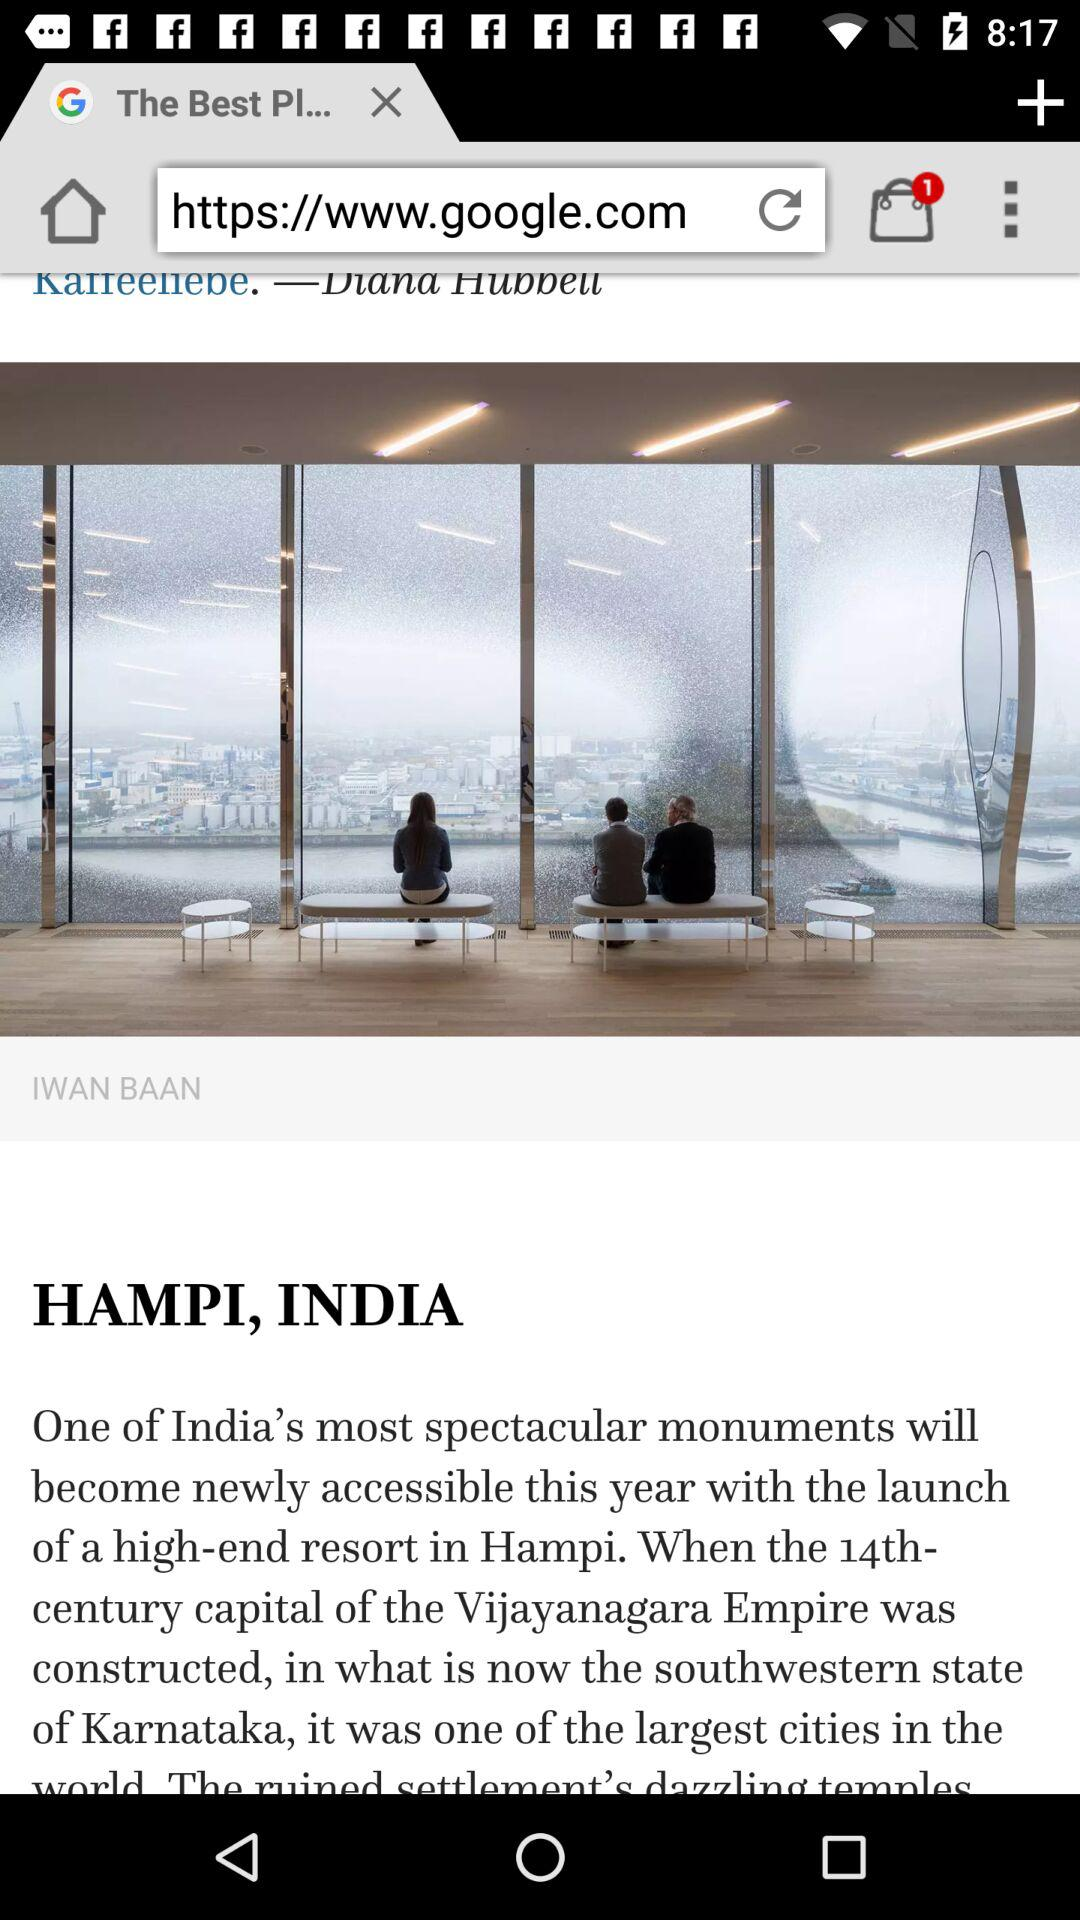What's the count of items in the bag? The count of items in the bag is 1. 